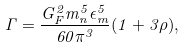Convert formula to latex. <formula><loc_0><loc_0><loc_500><loc_500>\Gamma = \frac { G ^ { 2 } _ { F } m ^ { 5 } _ { n } \epsilon ^ { 5 } _ { m } } { 6 0 \pi ^ { 3 } } ( 1 + 3 \rho ) ,</formula> 